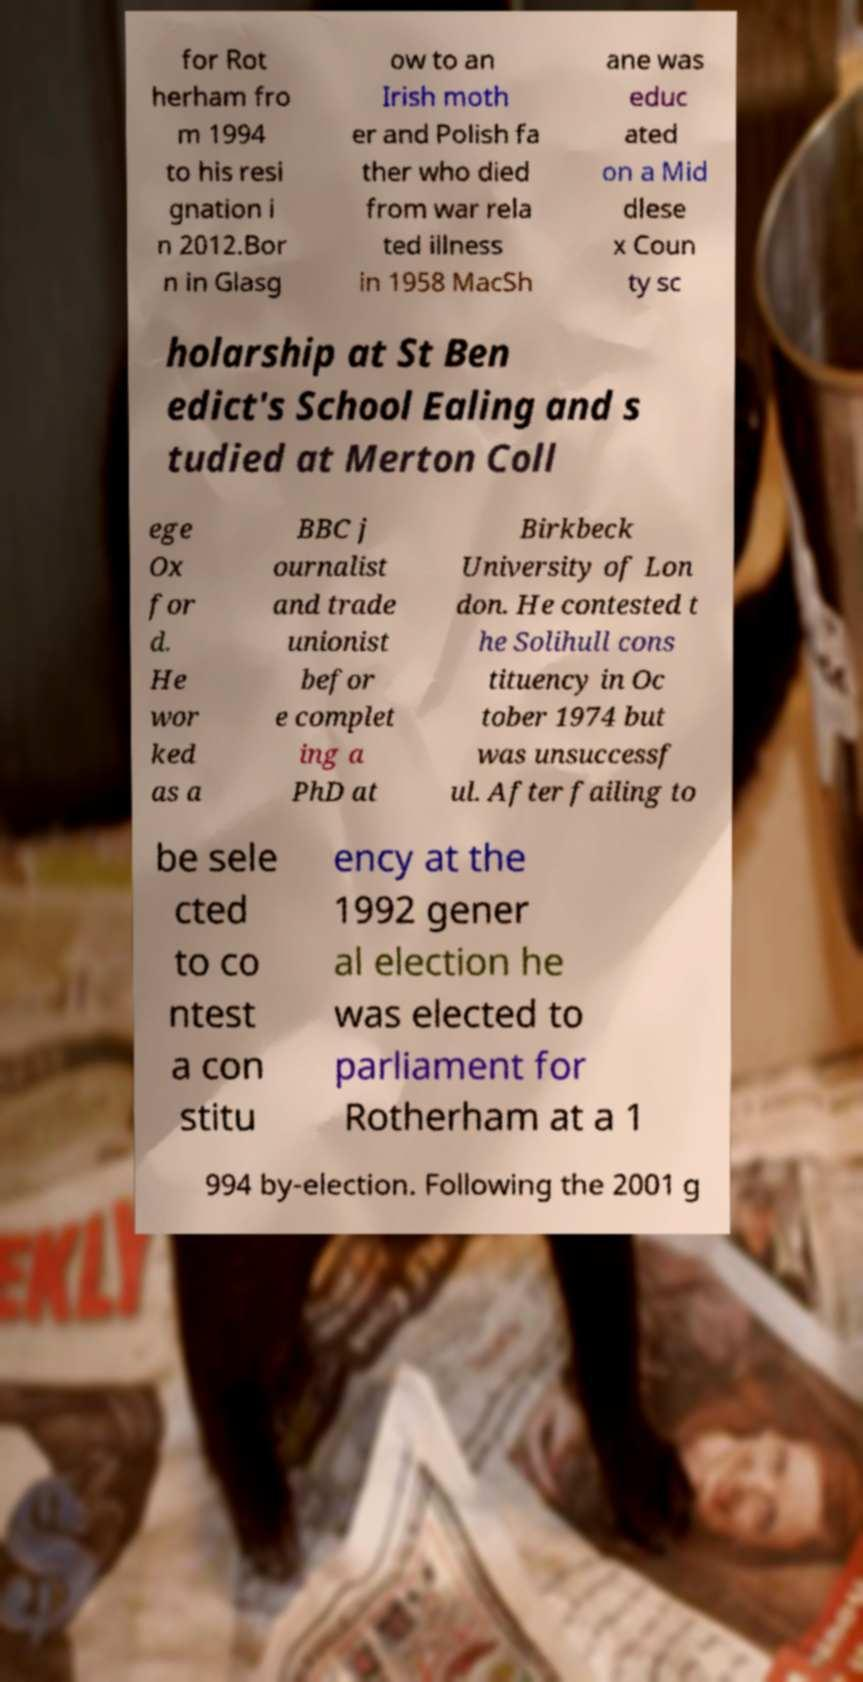Could you assist in decoding the text presented in this image and type it out clearly? for Rot herham fro m 1994 to his resi gnation i n 2012.Bor n in Glasg ow to an Irish moth er and Polish fa ther who died from war rela ted illness in 1958 MacSh ane was educ ated on a Mid dlese x Coun ty sc holarship at St Ben edict's School Ealing and s tudied at Merton Coll ege Ox for d. He wor ked as a BBC j ournalist and trade unionist befor e complet ing a PhD at Birkbeck University of Lon don. He contested t he Solihull cons tituency in Oc tober 1974 but was unsuccessf ul. After failing to be sele cted to co ntest a con stitu ency at the 1992 gener al election he was elected to parliament for Rotherham at a 1 994 by-election. Following the 2001 g 